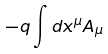<formula> <loc_0><loc_0><loc_500><loc_500>- q \int d x ^ { \mu } A _ { \mu }</formula> 